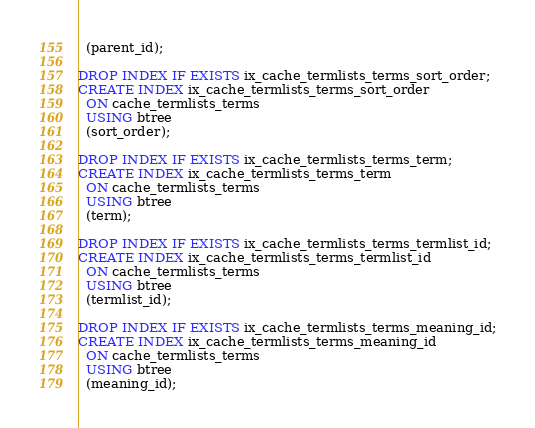Convert code to text. <code><loc_0><loc_0><loc_500><loc_500><_SQL_>  (parent_id);
  
DROP INDEX IF EXISTS ix_cache_termlists_terms_sort_order;
CREATE INDEX ix_cache_termlists_terms_sort_order
  ON cache_termlists_terms
  USING btree
  (sort_order);

DROP INDEX IF EXISTS ix_cache_termlists_terms_term;
CREATE INDEX ix_cache_termlists_terms_term
  ON cache_termlists_terms
  USING btree
  (term);
  
DROP INDEX IF EXISTS ix_cache_termlists_terms_termlist_id;
CREATE INDEX ix_cache_termlists_terms_termlist_id
  ON cache_termlists_terms
  USING btree
  (termlist_id);
  
DROP INDEX IF EXISTS ix_cache_termlists_terms_meaning_id;
CREATE INDEX ix_cache_termlists_terms_meaning_id
  ON cache_termlists_terms
  USING btree
  (meaning_id);
</code> 